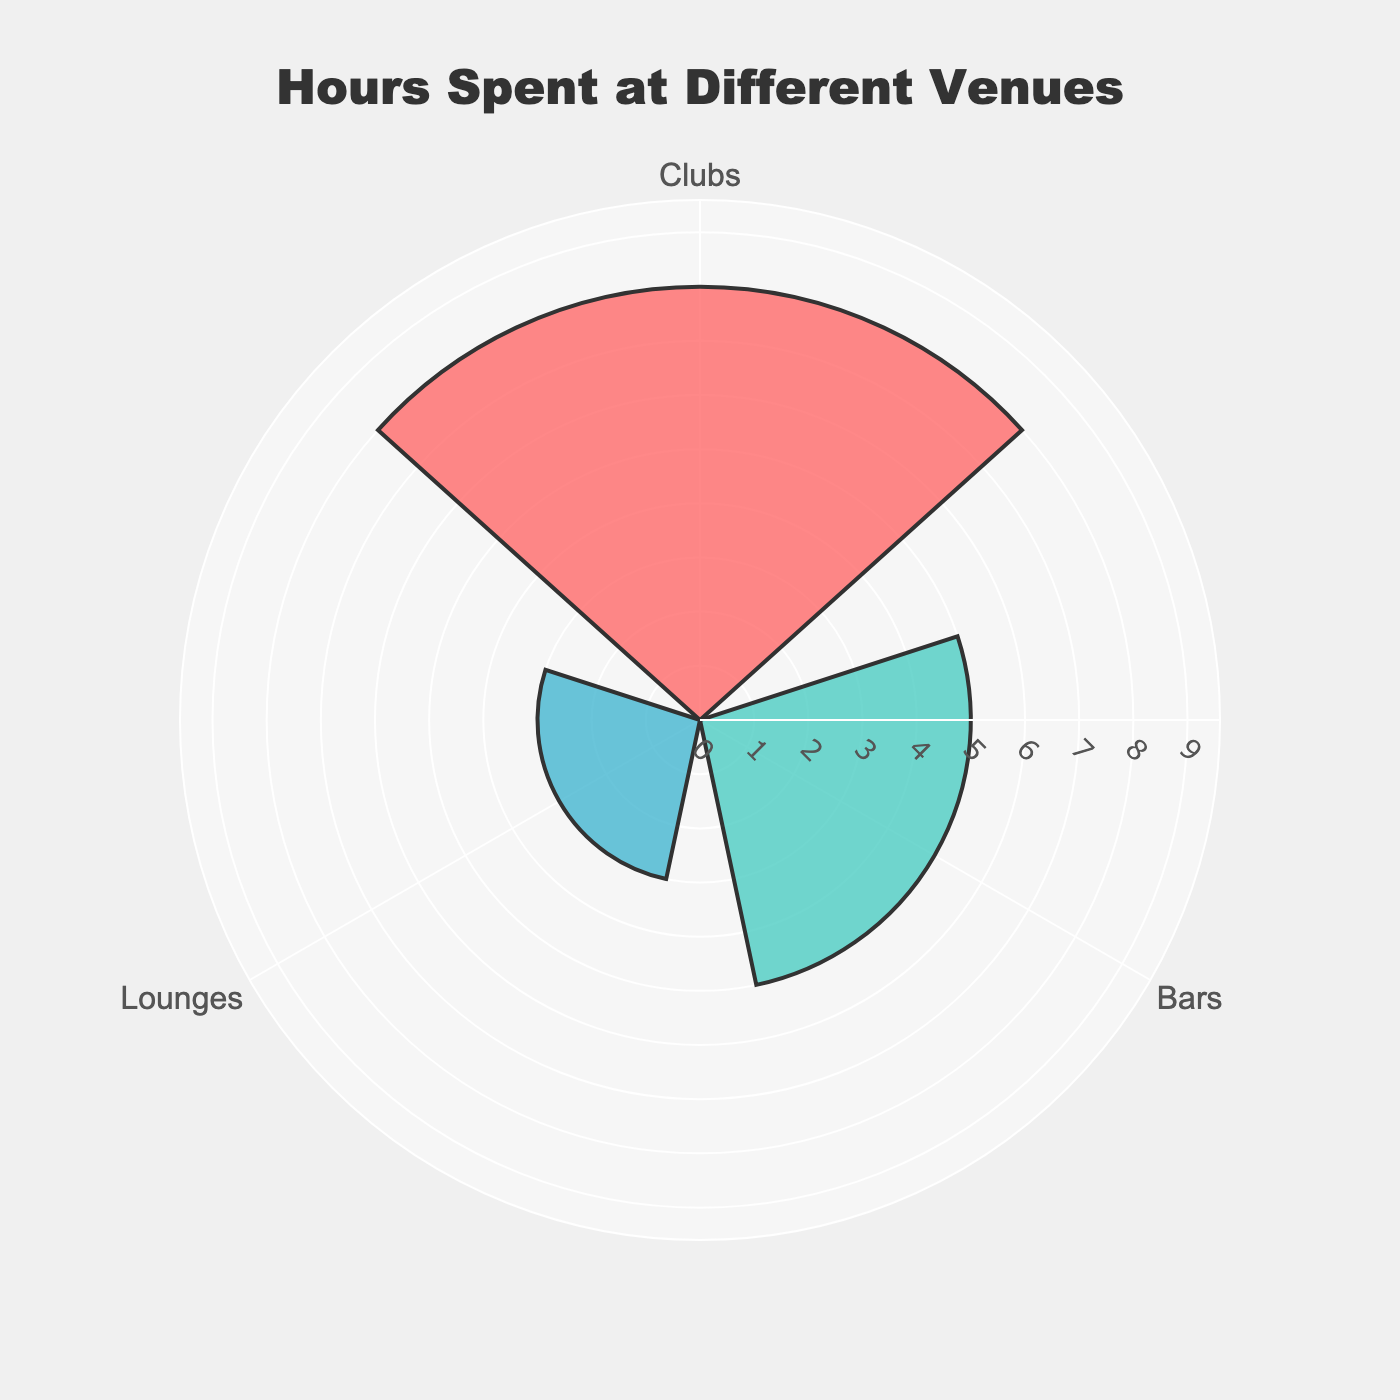What's the title of the figure? The title is prominently displayed at the top of the figure.
Answer: "Hours Spent at Different Venues" How many venue types are represented in the figure? The number of venue types can be counted from the different sections on the chart.
Answer: 3 Which venue type has the highest hours spent? The venue type with the longest bar/spread has the highest hours spent.
Answer: Clubs What are the total hours spent across all venue types? Add the hours spent at each venue: 8 (Clubs) + 5 (Bars) + 3 (Lounges) = 16
Answer: 16 Which venue type has the lowest hours spent? The venue type with the shortest bar/spread has the lowest hours spent.
Answer: Lounges How much more time is spent at clubs compared to lounges? Subtract the hours spent at Lounges from the hours spent at Clubs: 8 (Clubs) - 3 (Lounges) = 5
Answer: 5 Do the bars or lounges have more hours spent, and by how much? Compare the hours spent at Bars and Lounges: 5 (Bars) - 3 (Lounges) = 2
Answer: Bars, by 2 What percentage of the total hours is spent at bars? Calculate the percentage of hours spent at Bars out of the total hours: \( \left(\frac{5}{16}\right) \times 100 \approx 31.25\% \)
Answer: 31.25% What's the average hours spent across the venue types? Calculate the average by summing the hours and dividing by the number of venue types: \( \frac{8 + 5 + 3}{3} = 5.33 \)
Answer: 5.33 If you combined the time spent at bars and lounges, what would the total be? Add the hours spent at Bars and Lounges: 5 (Bars) + 3 (Lounges) = 8
Answer: 8 